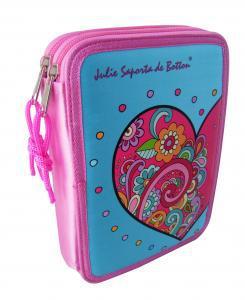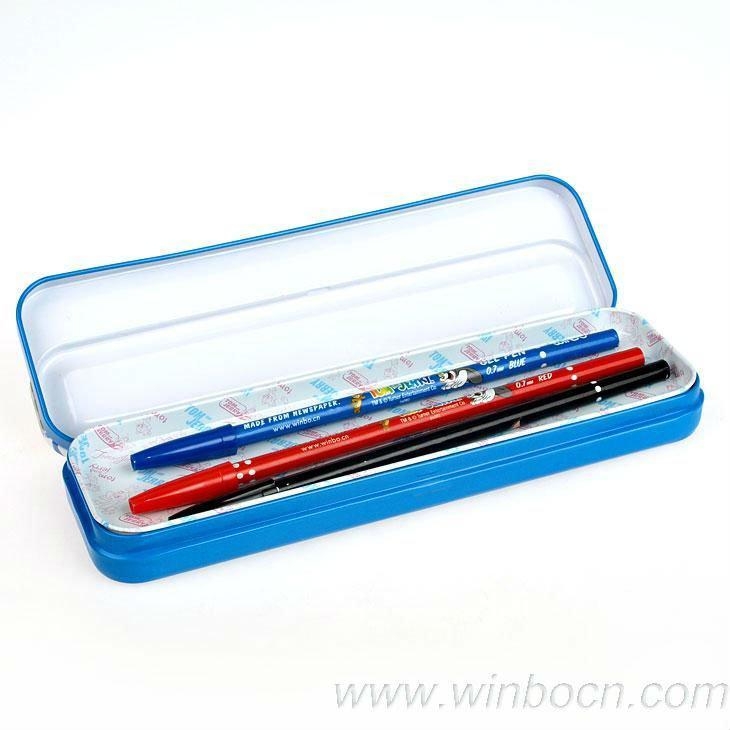The first image is the image on the left, the second image is the image on the right. Considering the images on both sides, is "The image to the left features exactly one case, and it is open." valid? Answer yes or no. No. 